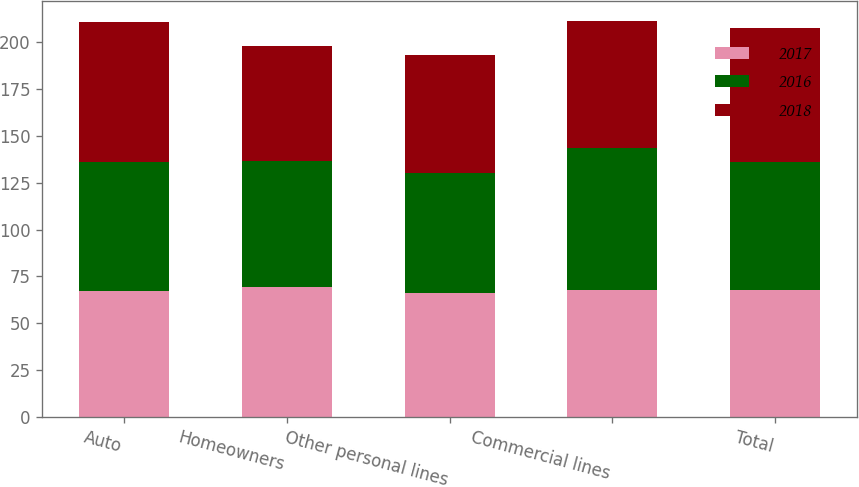<chart> <loc_0><loc_0><loc_500><loc_500><stacked_bar_chart><ecel><fcel>Auto<fcel>Homeowners<fcel>Other personal lines<fcel>Commercial lines<fcel>Total<nl><fcel>2017<fcel>67<fcel>69.5<fcel>66.2<fcel>68<fcel>68<nl><fcel>2016<fcel>68.9<fcel>67.2<fcel>64<fcel>75.5<fcel>68.3<nl><fcel>2018<fcel>74.7<fcel>61.3<fcel>62.9<fcel>68<fcel>71.2<nl></chart> 